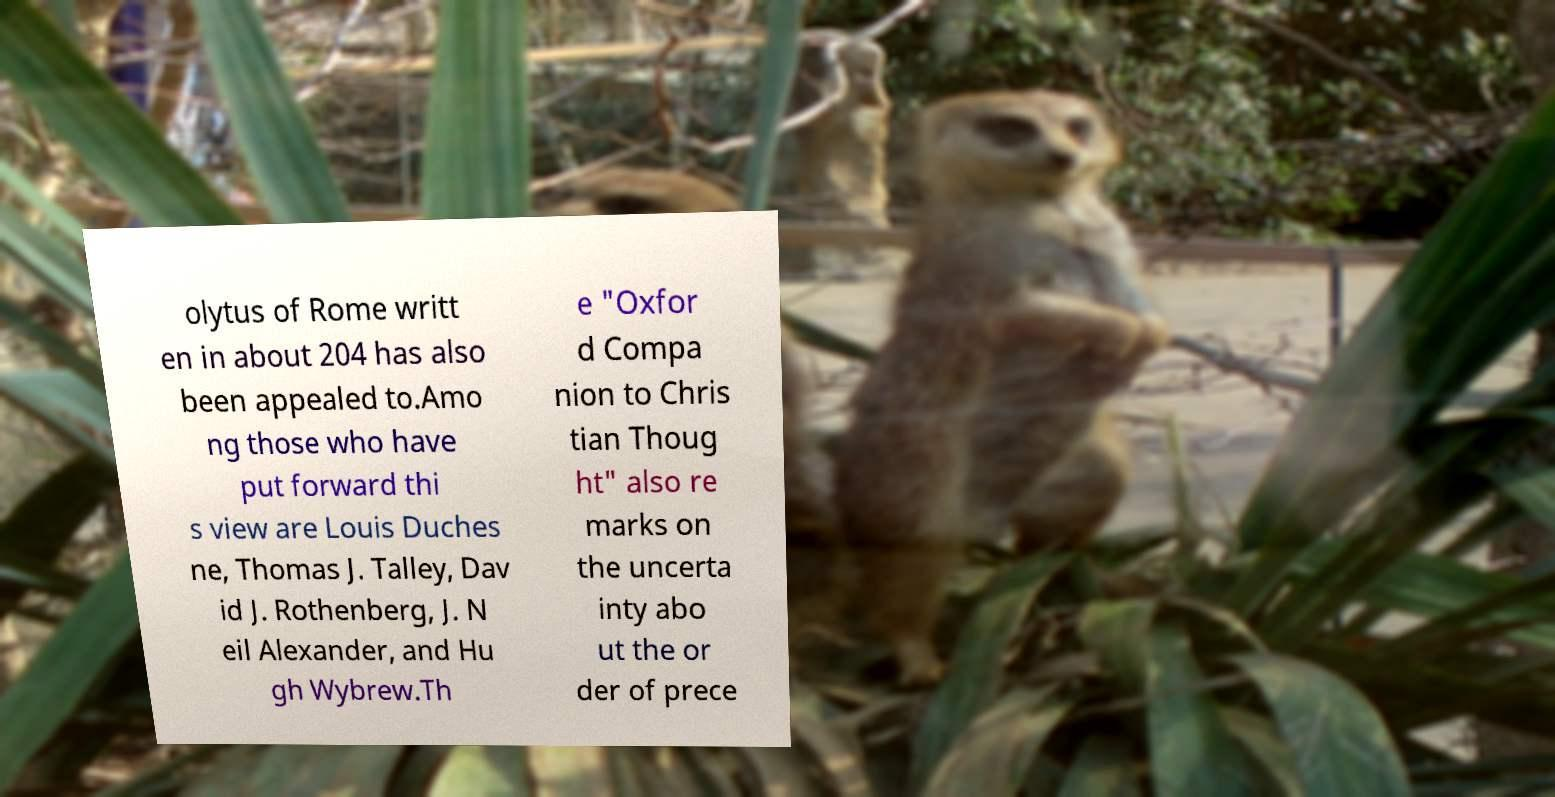I need the written content from this picture converted into text. Can you do that? olytus of Rome writt en in about 204 has also been appealed to.Amo ng those who have put forward thi s view are Louis Duches ne, Thomas J. Talley, Dav id J. Rothenberg, J. N eil Alexander, and Hu gh Wybrew.Th e "Oxfor d Compa nion to Chris tian Thoug ht" also re marks on the uncerta inty abo ut the or der of prece 